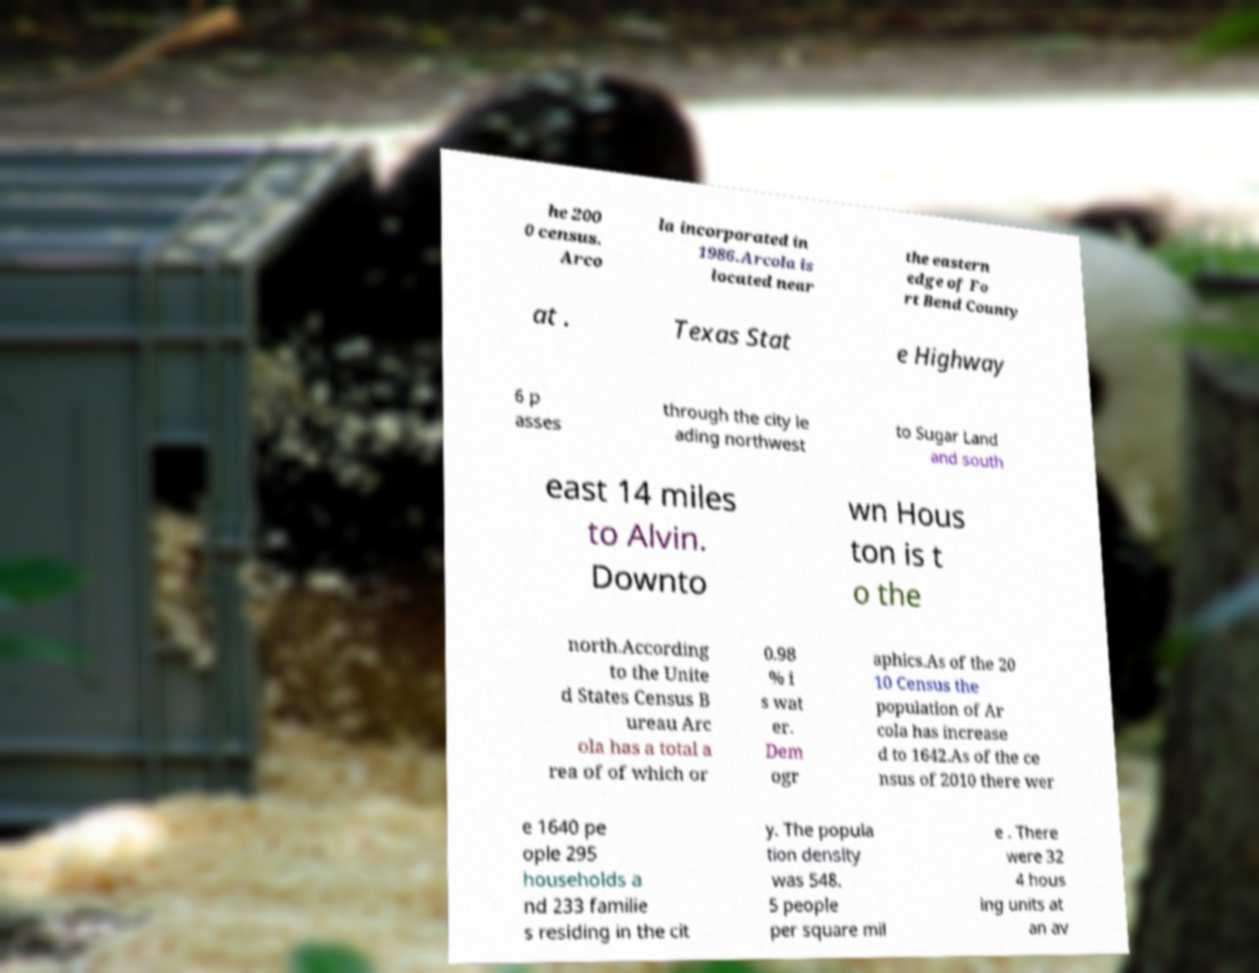I need the written content from this picture converted into text. Can you do that? he 200 0 census. Arco la incorporated in 1986.Arcola is located near the eastern edge of Fo rt Bend County at . Texas Stat e Highway 6 p asses through the city le ading northwest to Sugar Land and south east 14 miles to Alvin. Downto wn Hous ton is t o the north.According to the Unite d States Census B ureau Arc ola has a total a rea of of which or 0.98 % i s wat er. Dem ogr aphics.As of the 20 10 Census the population of Ar cola has increase d to 1642.As of the ce nsus of 2010 there wer e 1640 pe ople 295 households a nd 233 familie s residing in the cit y. The popula tion density was 548. 5 people per square mil e . There were 32 4 hous ing units at an av 